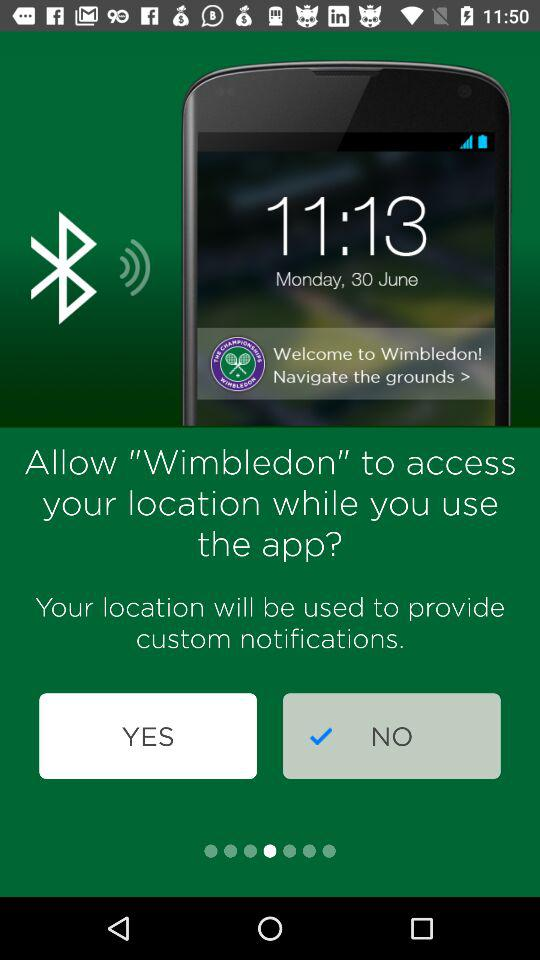What is the name of the application asking for access to my location? The name of the application is "Wimbledon". 